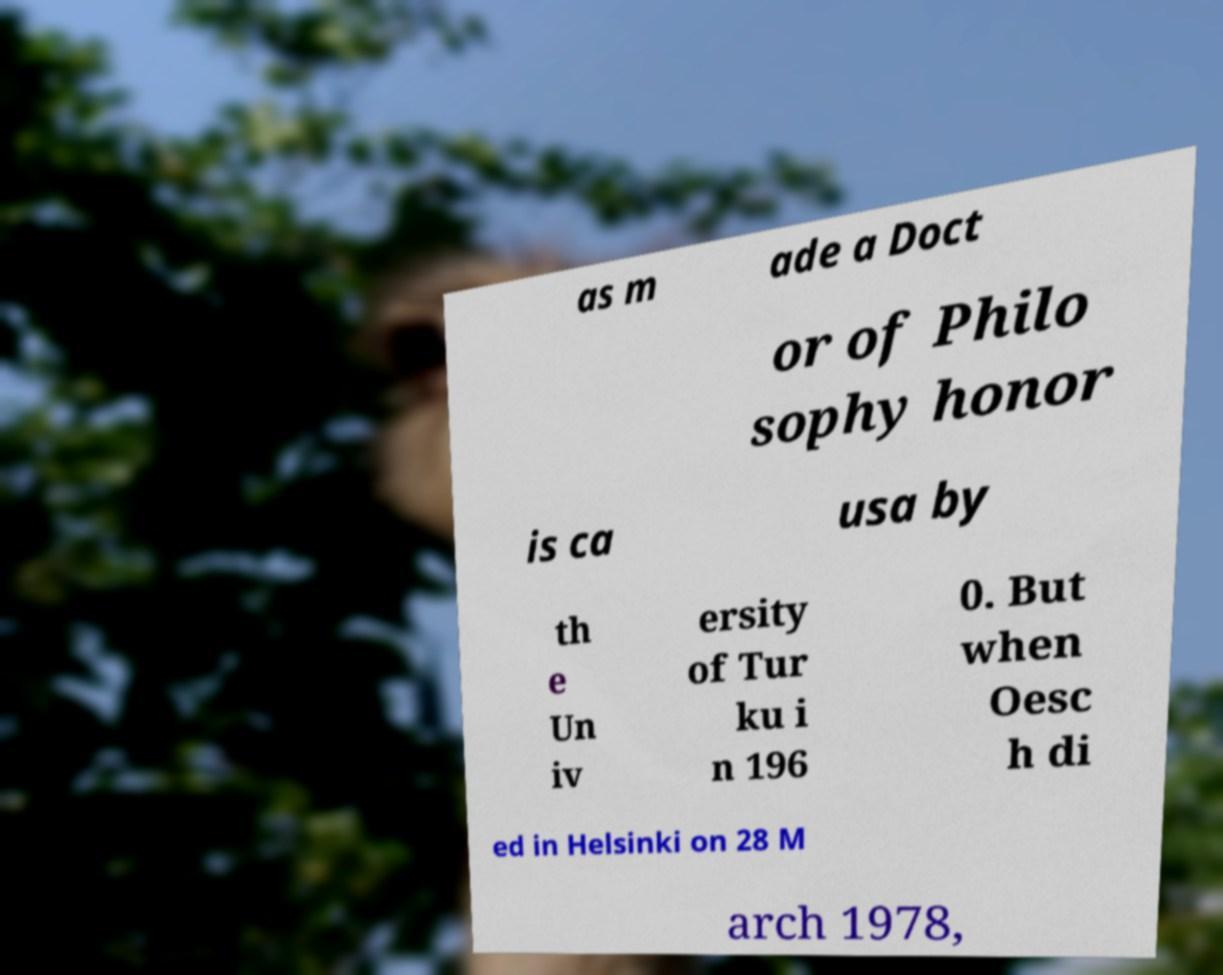For documentation purposes, I need the text within this image transcribed. Could you provide that? as m ade a Doct or of Philo sophy honor is ca usa by th e Un iv ersity of Tur ku i n 196 0. But when Oesc h di ed in Helsinki on 28 M arch 1978, 